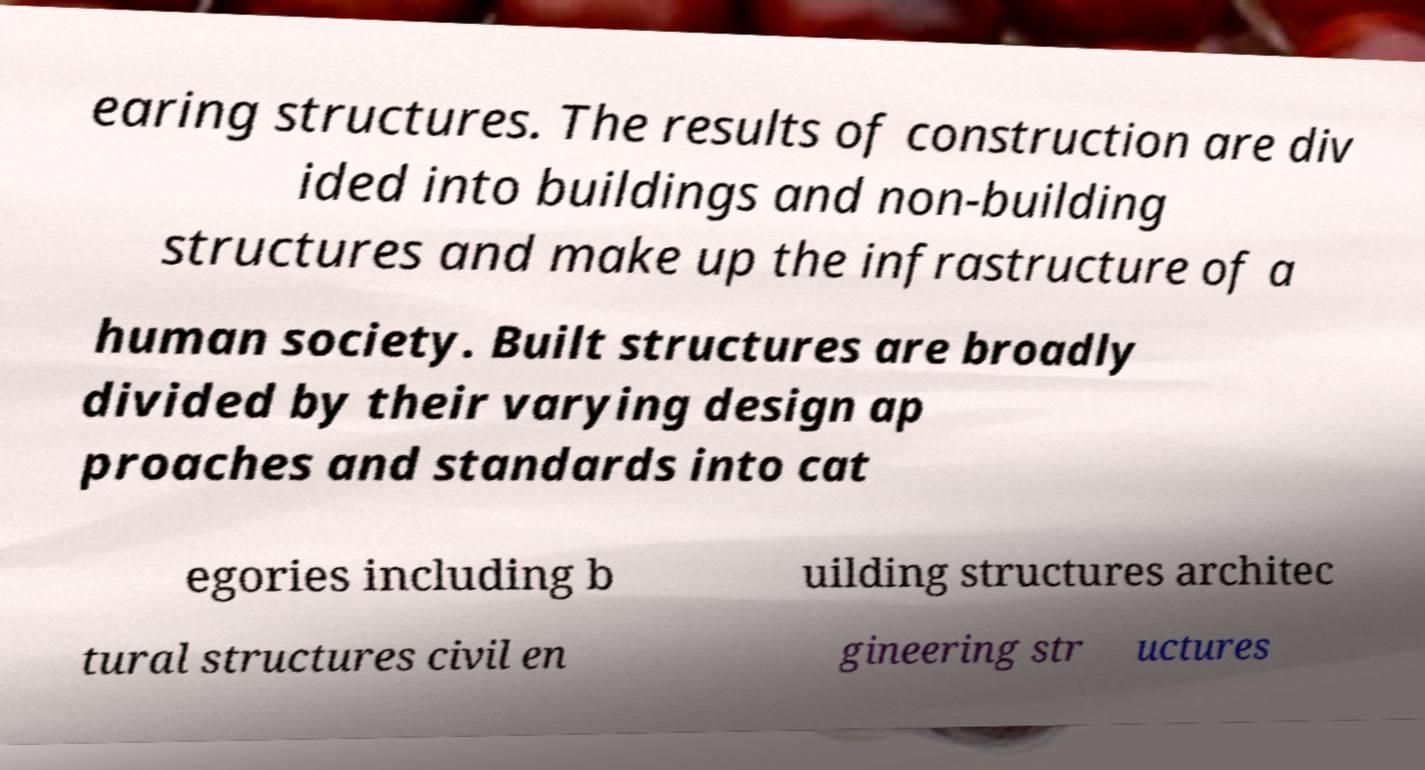Can you read and provide the text displayed in the image?This photo seems to have some interesting text. Can you extract and type it out for me? earing structures. The results of construction are div ided into buildings and non-building structures and make up the infrastructure of a human society. Built structures are broadly divided by their varying design ap proaches and standards into cat egories including b uilding structures architec tural structures civil en gineering str uctures 